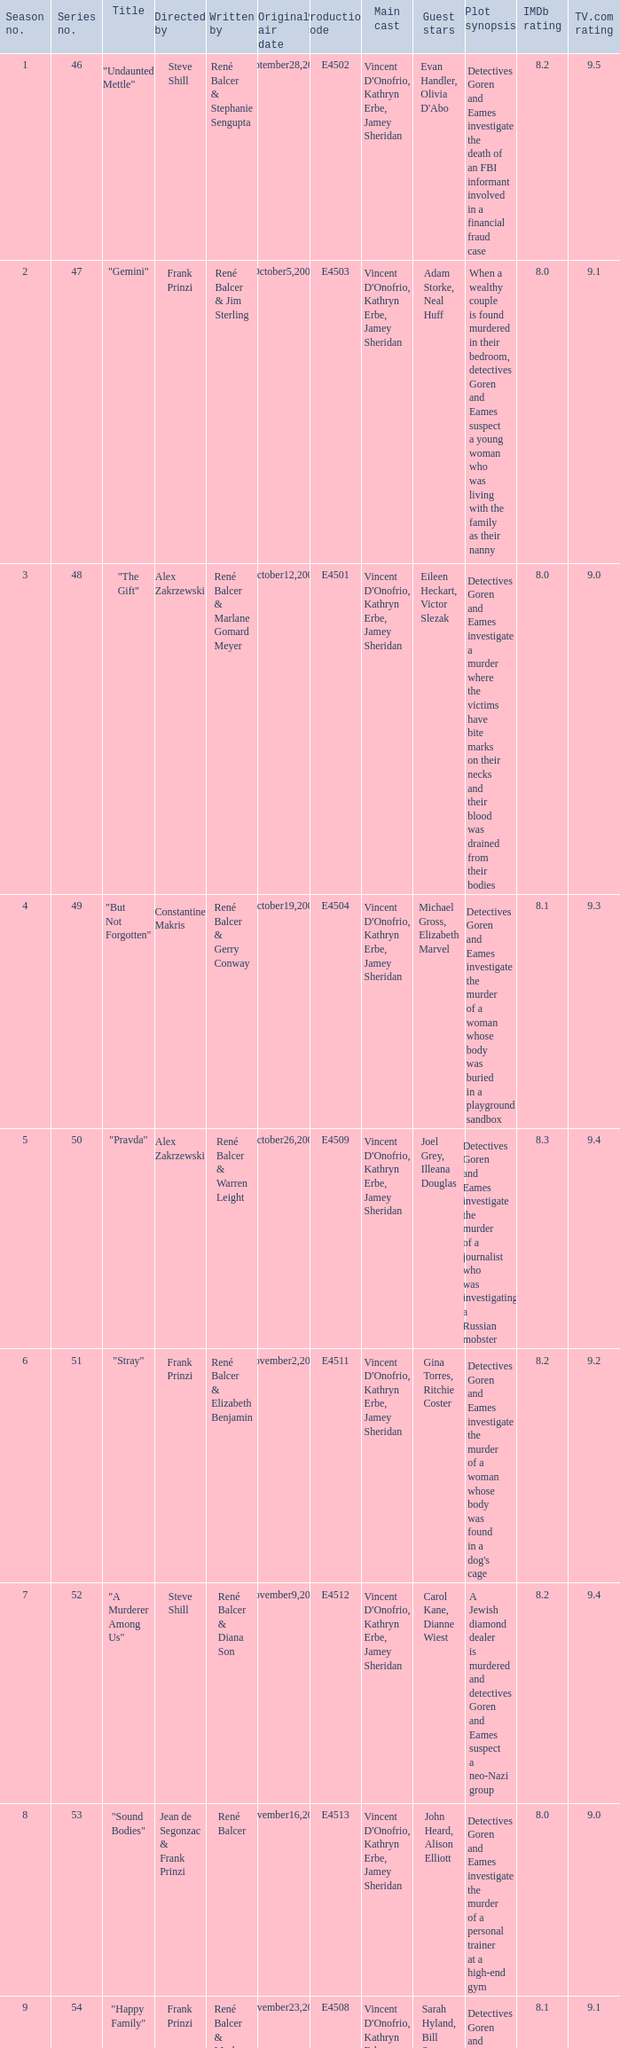What episode number in the season is titled "stray"? 6.0. 